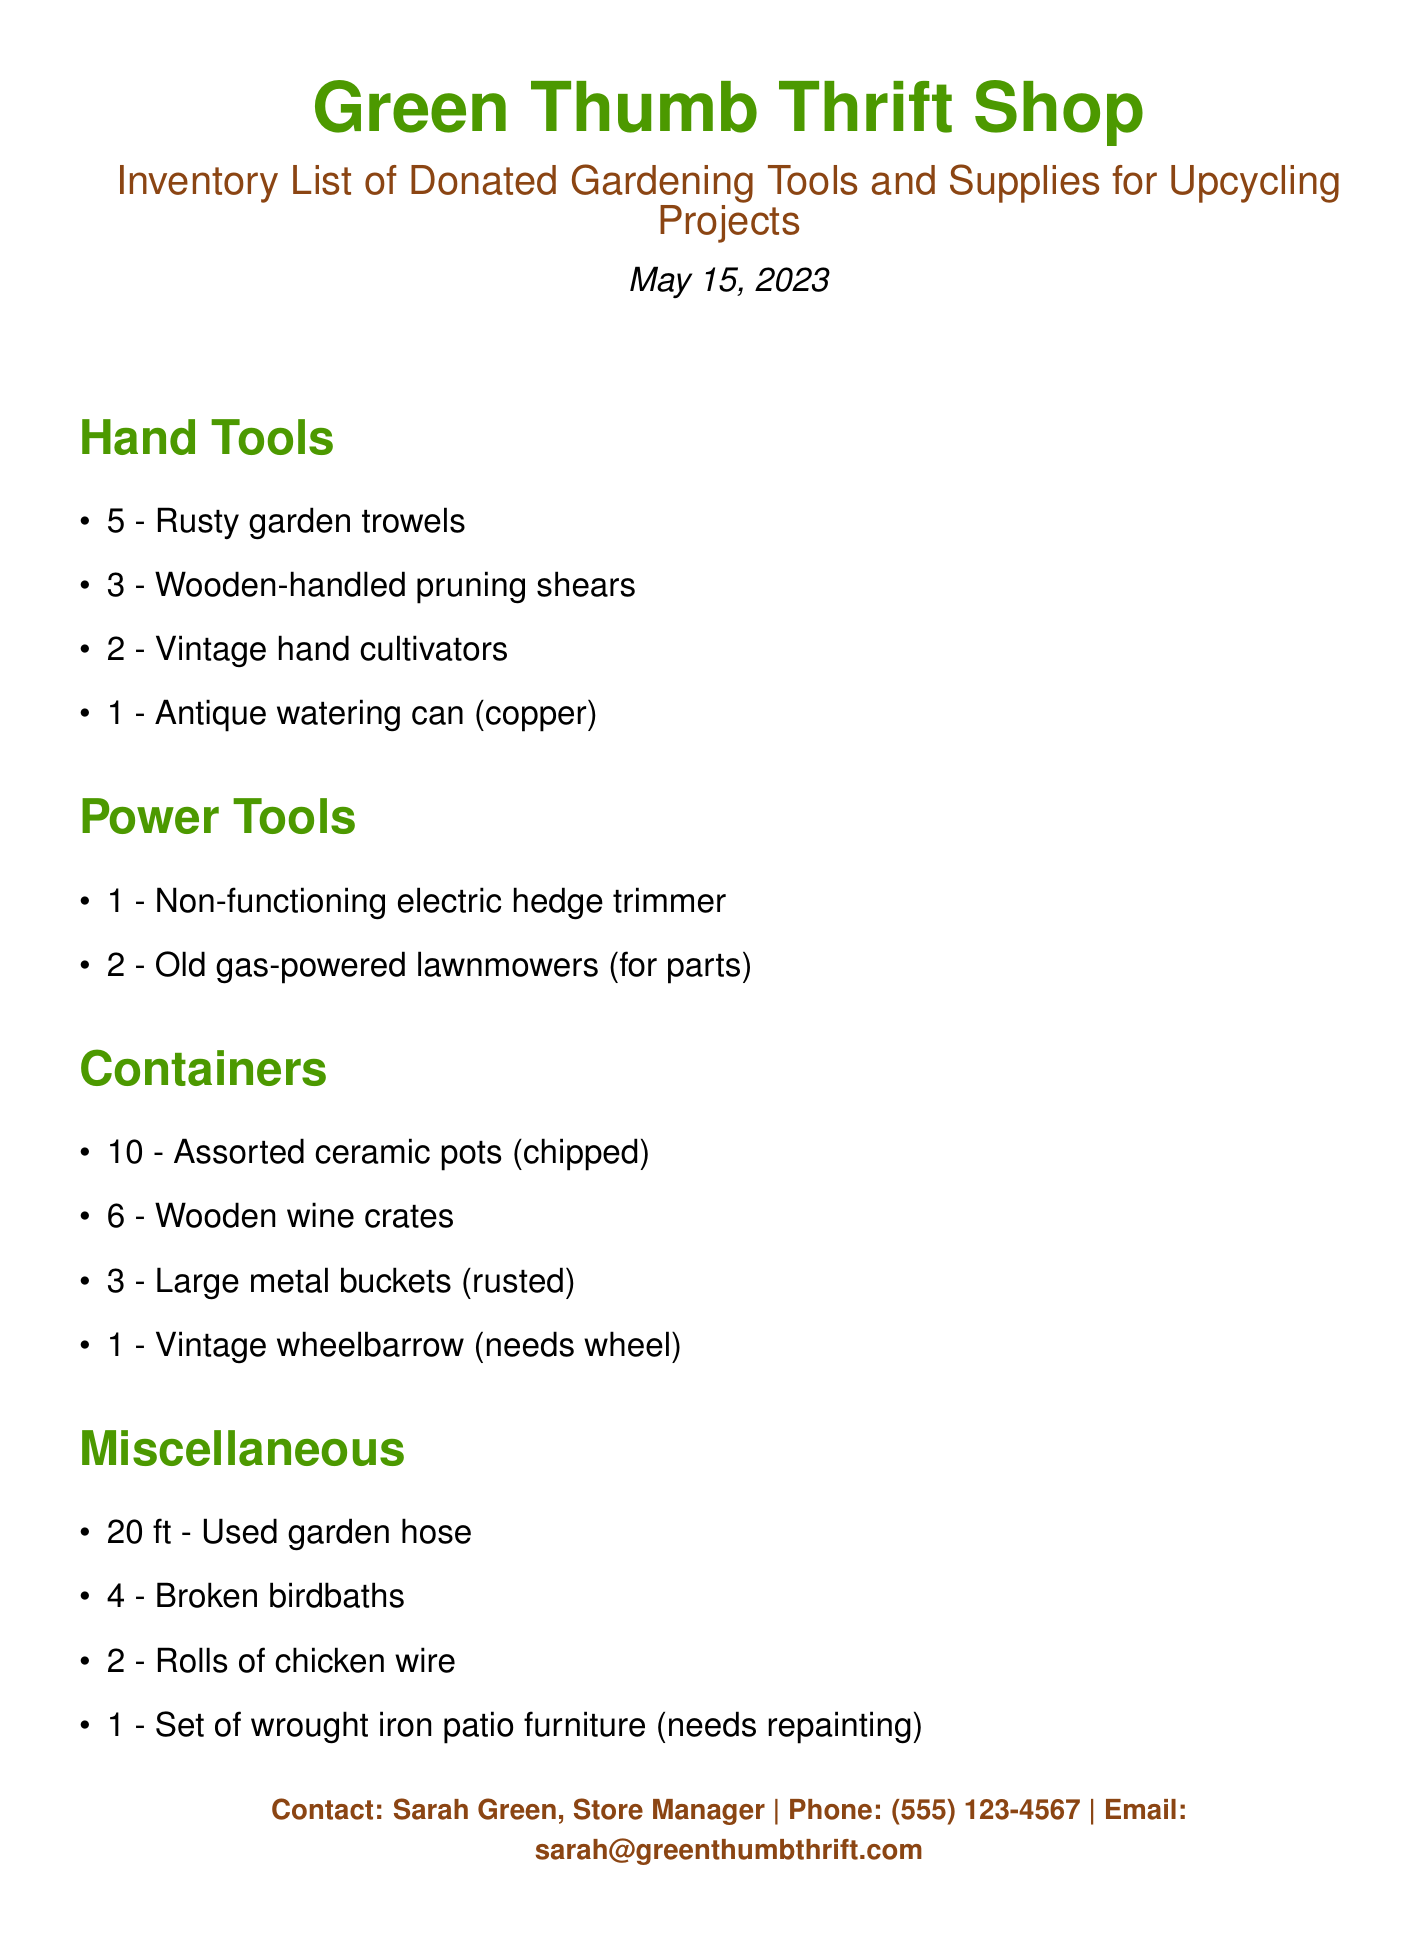What is the date of the inventory list? The date is stated at the top of the document as May 15, 2023.
Answer: May 15, 2023 How many wooden-handled pruning shears are listed? The number of wooden-handled pruning shears is mentioned in the Hand Tools section of the document.
Answer: 3 What type of furniture needs repainting? The specific item requiring repainting is explicitly identified in the Miscellaneous section of the document.
Answer: Wrought iron patio furniture How many ceramic pots are chipped? The document specifies the quantity and condition of the ceramic pots under the Containers section.
Answer: 10 What is the total number of old gas-powered lawnmowers? The total number is given in the Power Tools section, which lists the items available.
Answer: 2 What type of watering can is mentioned? The type is indicated in the Hand Tools section, describing the specific features of the item.
Answer: Antique (copper) Which item in the inventory is associated with rust? The items are specifically described in their respective sections, including relevant conditions.
Answer: Large metal buckets (rusted) What is the contact email for the store manager? The contact information at the bottom of the document includes the email.
Answer: sarah@greenthumbthrift.com How many broken birdbaths are listed? The quantity of broken birdbaths is stated under the Miscellaneous section.
Answer: 4 